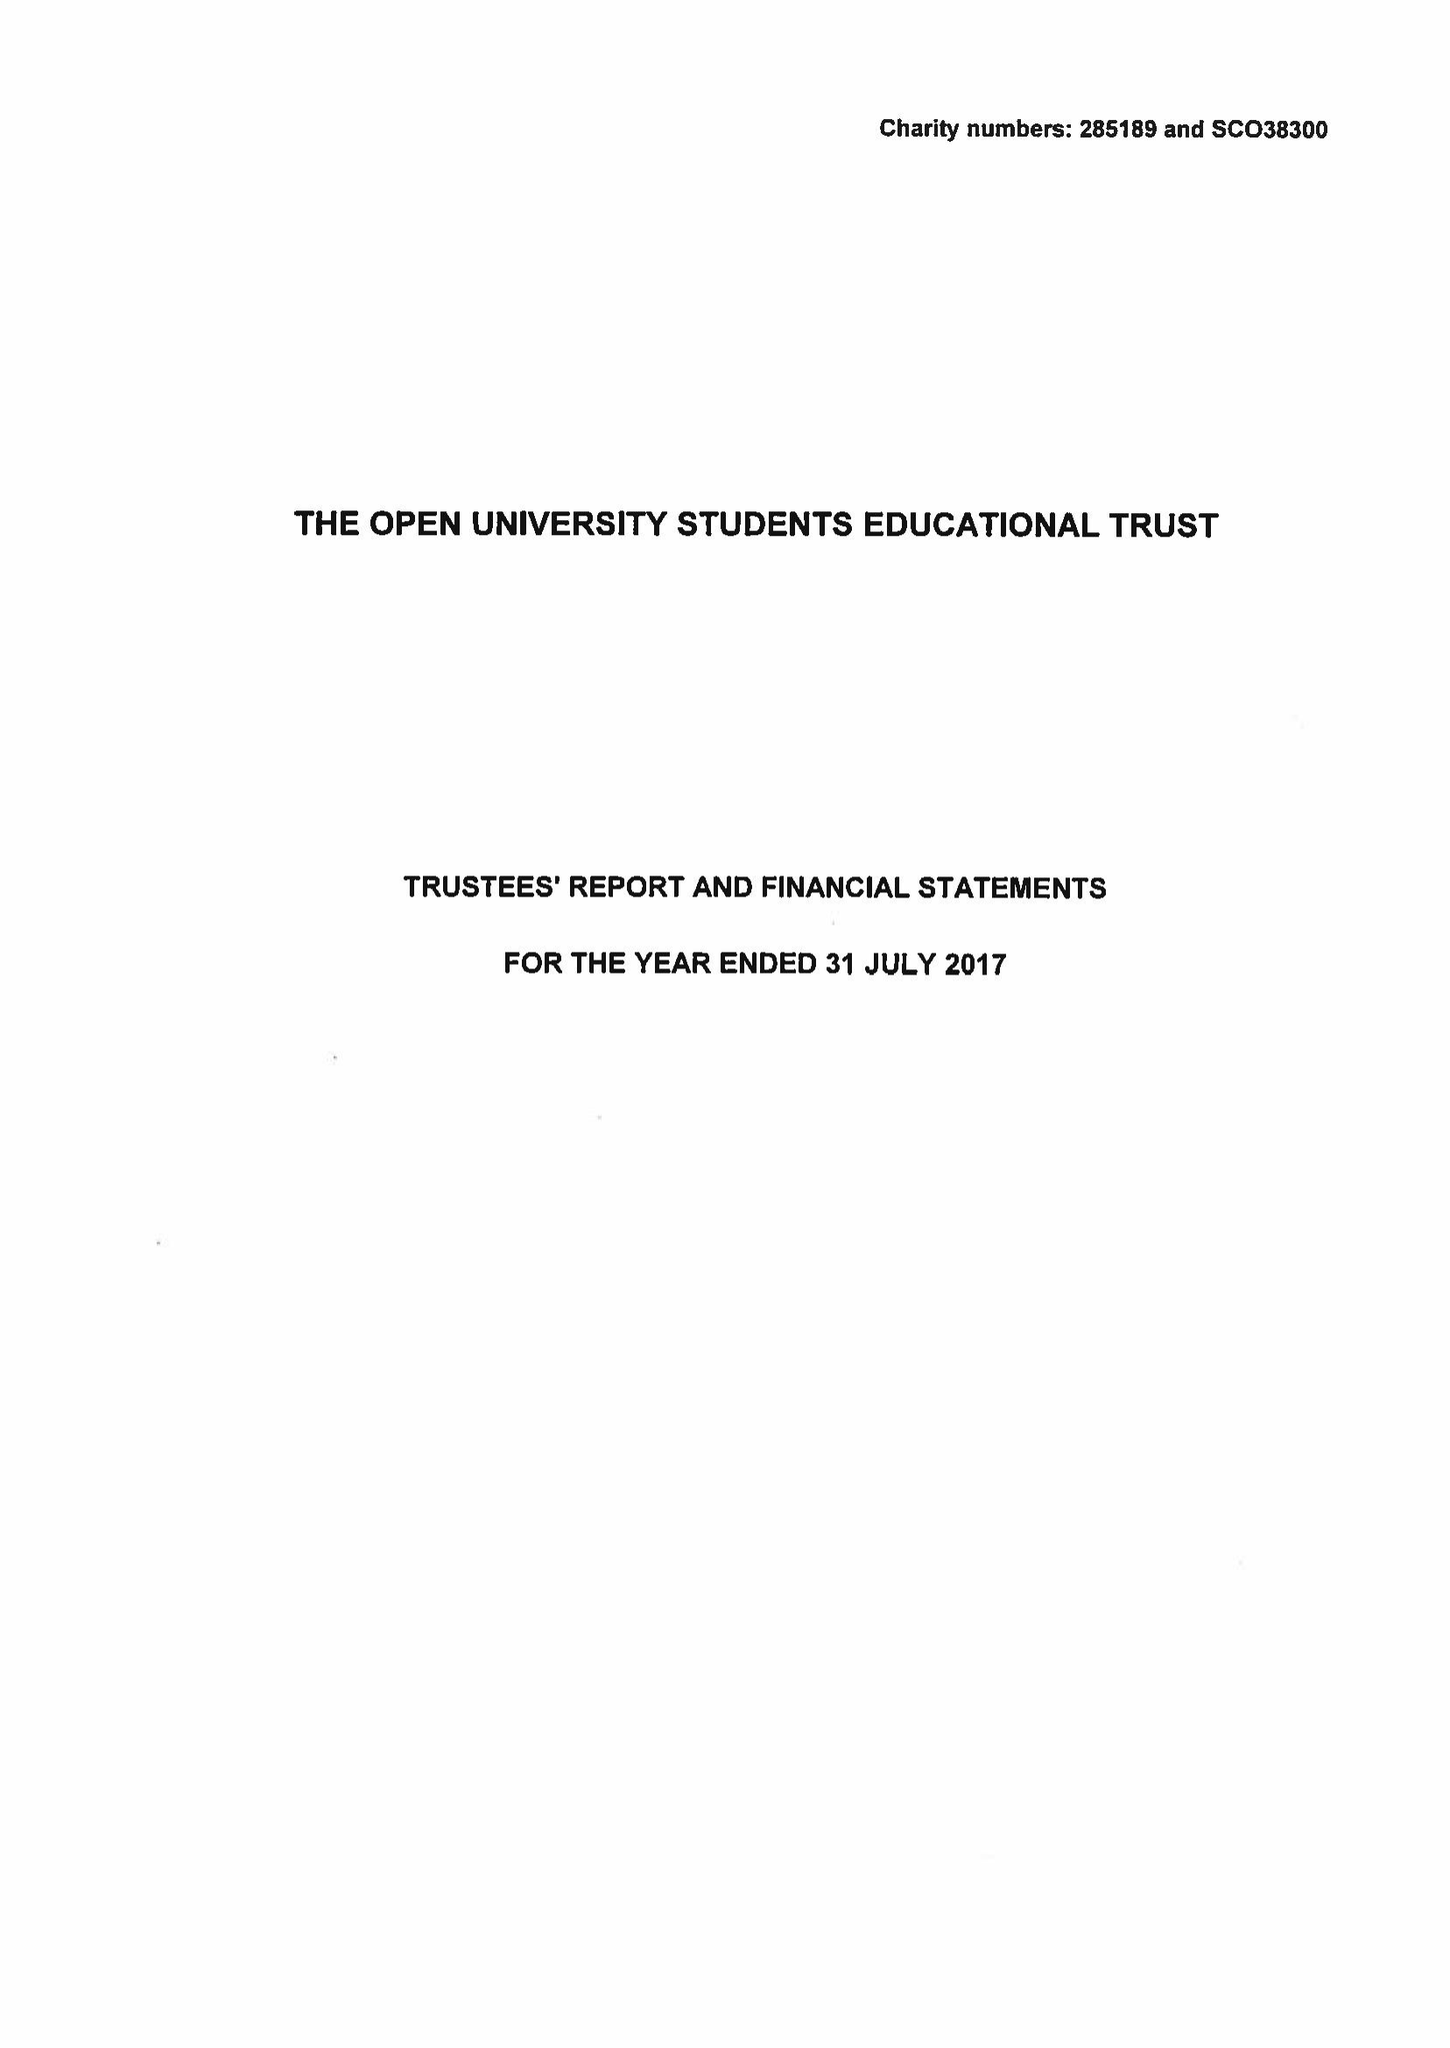What is the value for the address__postcode?
Answer the question using a single word or phrase. MK7 6BE 